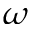Convert formula to latex. <formula><loc_0><loc_0><loc_500><loc_500>\omega</formula> 